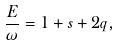<formula> <loc_0><loc_0><loc_500><loc_500>\frac { E } { \omega } = 1 + s + 2 q ,</formula> 